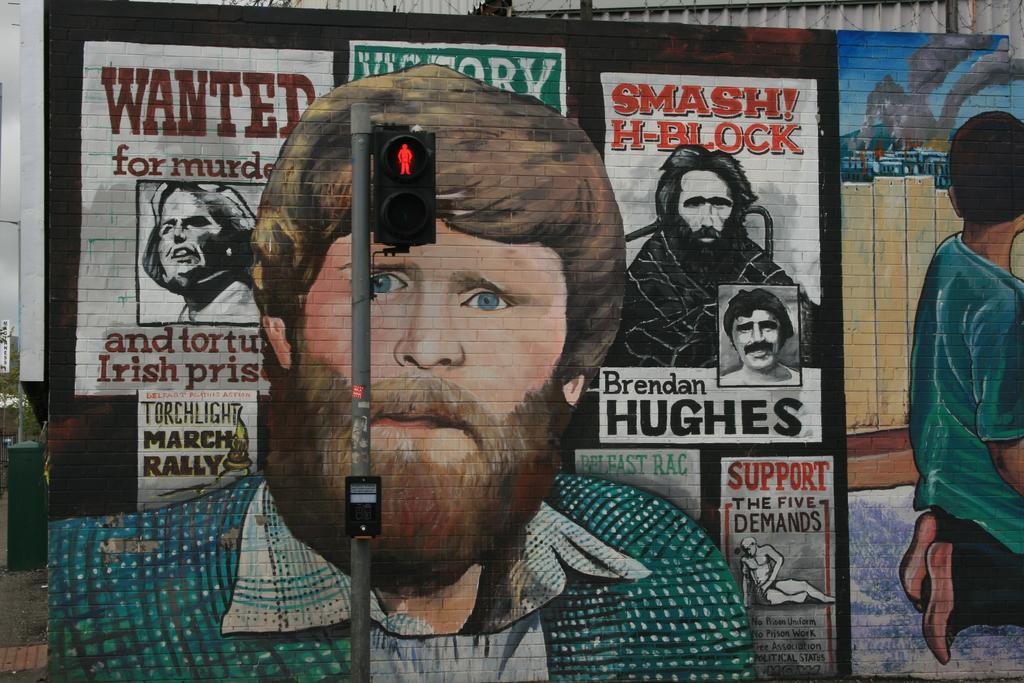In one or two sentences, can you explain what this image depicts? In the middle of the image there is a pole with a traffic signal. Behind the pole there is a wall with paintings of a few people and some other things. And also there is some text on the wall. 